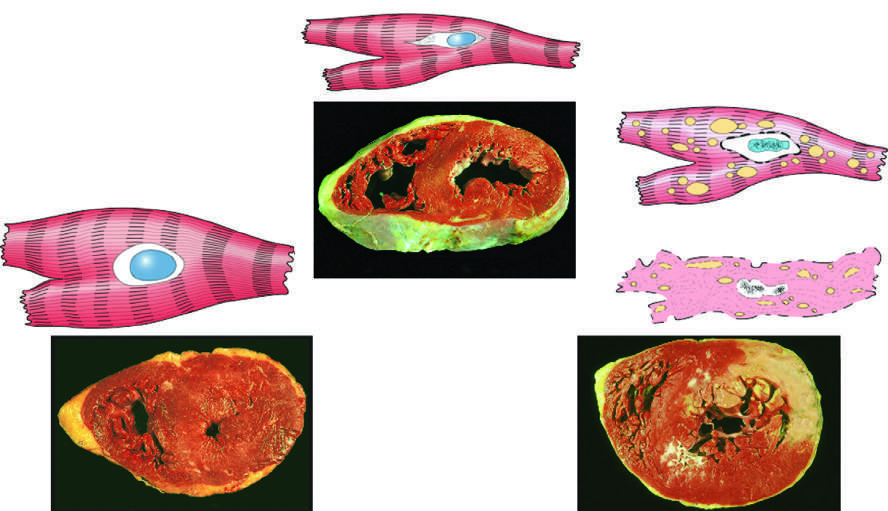how many transverse sections of myocardium were stained with triphenyltetra-zolium chloride, an enzyme substrate that colors viable myocardium magenta?
Answer the question using a single word or phrase. Three 